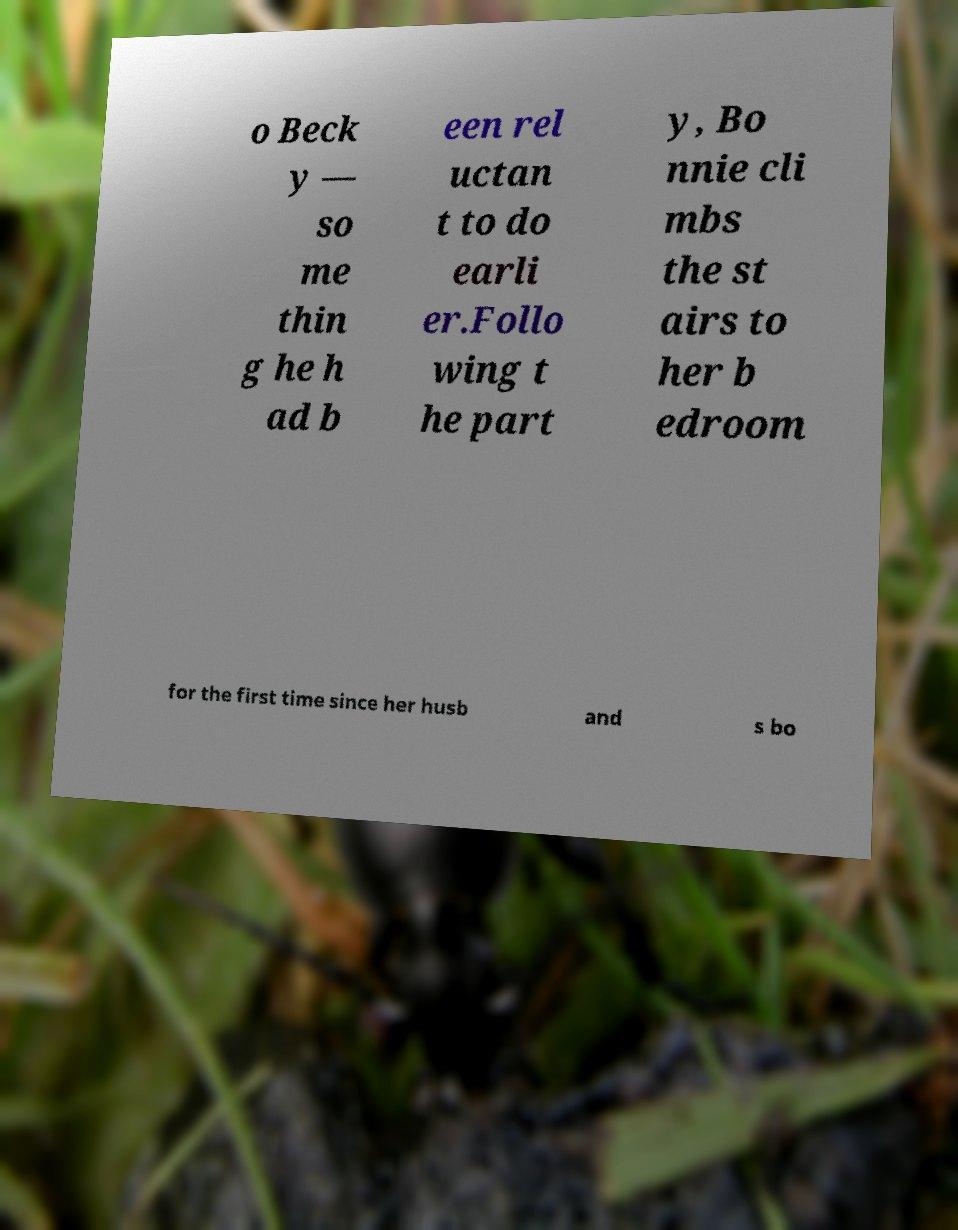Could you assist in decoding the text presented in this image and type it out clearly? o Beck y — so me thin g he h ad b een rel uctan t to do earli er.Follo wing t he part y, Bo nnie cli mbs the st airs to her b edroom for the first time since her husb and s bo 